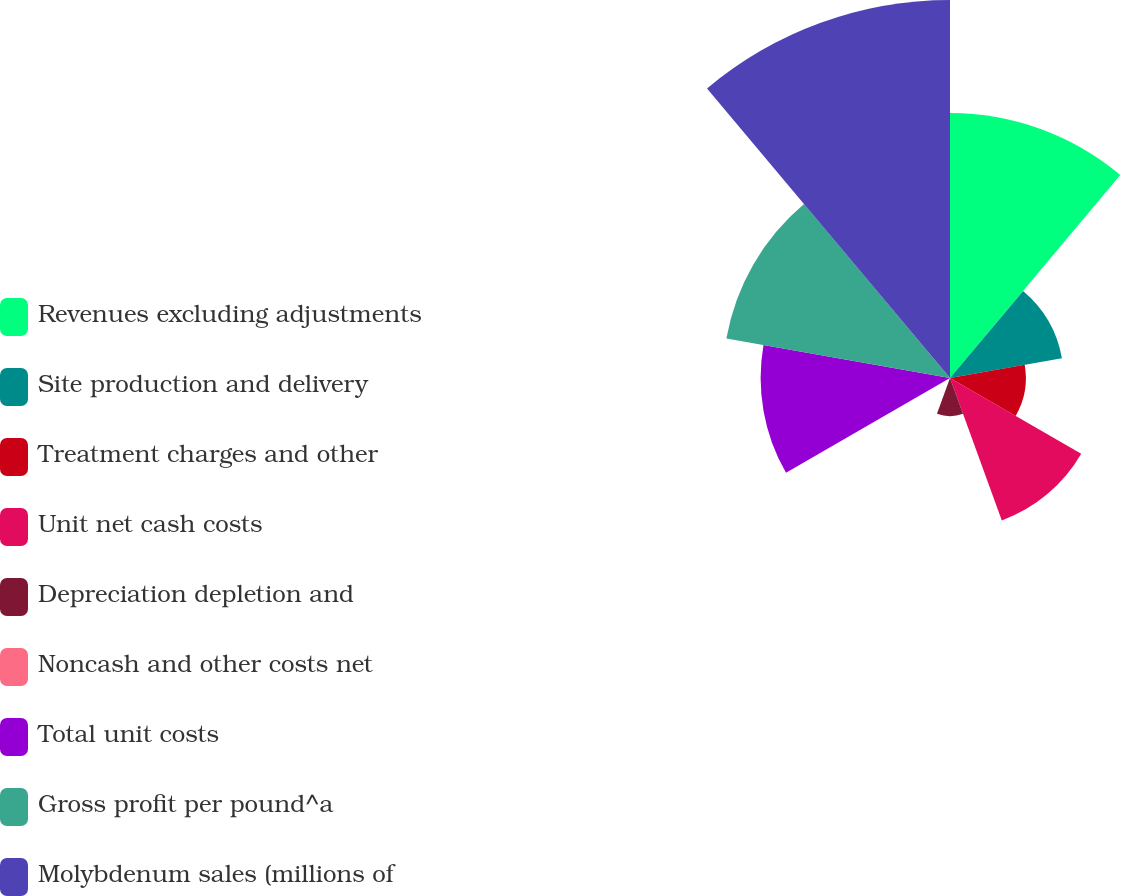Convert chart to OTSL. <chart><loc_0><loc_0><loc_500><loc_500><pie_chart><fcel>Revenues excluding adjustments<fcel>Site production and delivery<fcel>Treatment charges and other<fcel>Unit net cash costs<fcel>Depreciation depletion and<fcel>Noncash and other costs net<fcel>Total unit costs<fcel>Gross profit per pound^a<fcel>Molybdenum sales (millions of<nl><fcel>18.41%<fcel>7.9%<fcel>5.27%<fcel>10.53%<fcel>2.65%<fcel>0.02%<fcel>13.16%<fcel>15.78%<fcel>26.27%<nl></chart> 